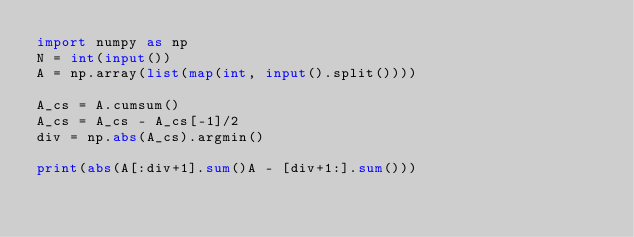Convert code to text. <code><loc_0><loc_0><loc_500><loc_500><_Python_>import numpy as np
N = int(input())
A = np.array(list(map(int, input().split())))

A_cs = A.cumsum()
A_cs = A_cs - A_cs[-1]/2
div = np.abs(A_cs).argmin()

print(abs(A[:div+1].sum()A - [div+1:].sum()))</code> 